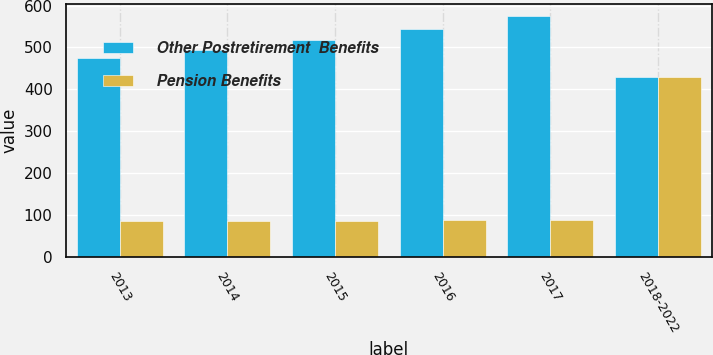<chart> <loc_0><loc_0><loc_500><loc_500><stacked_bar_chart><ecel><fcel>2013<fcel>2014<fcel>2015<fcel>2016<fcel>2017<fcel>2018-2022<nl><fcel>Other Postretirement  Benefits<fcel>475<fcel>495<fcel>519<fcel>545<fcel>574<fcel>430<nl><fcel>Pension Benefits<fcel>85<fcel>86<fcel>86<fcel>87<fcel>87<fcel>430<nl></chart> 